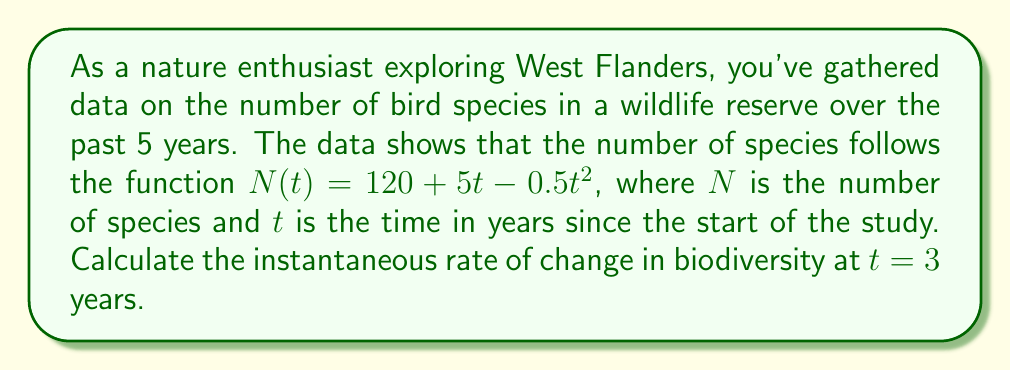Provide a solution to this math problem. To solve this problem, we need to find the derivative of the given function and evaluate it at $t = 3$. This will give us the instantaneous rate of change in biodiversity at that point in time.

1) The given function is:
   $N(t) = 120 + 5t - 0.5t^2$

2) To find the rate of change, we need to differentiate $N(t)$ with respect to $t$:
   $$\frac{dN}{dt} = \frac{d}{dt}(120 + 5t - 0.5t^2)$$

3) Using the power rule and the constant rule of differentiation:
   $$\frac{dN}{dt} = 0 + 5 - 0.5 \cdot 2t$$
   $$\frac{dN}{dt} = 5 - t$$

4) Now, we need to evaluate this derivative at $t = 3$:
   $$\frac{dN}{dt}\bigg|_{t=3} = 5 - 3 = 2$$

Therefore, the instantaneous rate of change in biodiversity at $t = 3$ years is 2 species per year.
Answer: 2 species per year 